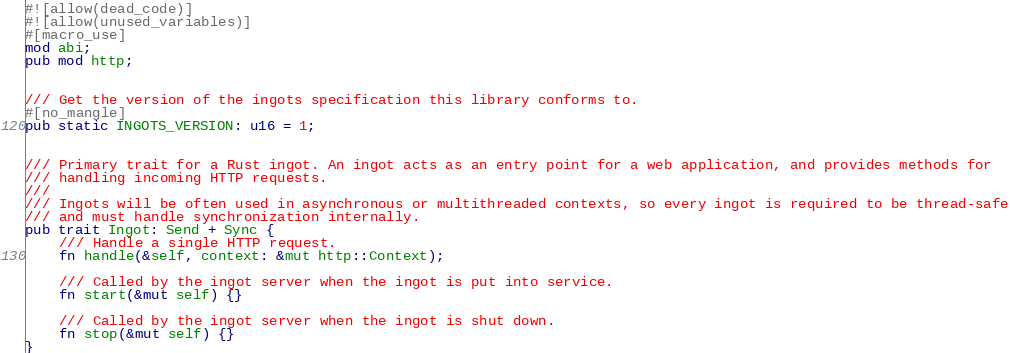<code> <loc_0><loc_0><loc_500><loc_500><_Rust_>#![allow(dead_code)]
#![allow(unused_variables)]
#[macro_use]
mod abi;
pub mod http;


/// Get the version of the ingots specification this library conforms to.
#[no_mangle]
pub static INGOTS_VERSION: u16 = 1;


/// Primary trait for a Rust ingot. An ingot acts as an entry point for a web application, and provides methods for
/// handling incoming HTTP requests.
///
/// Ingots will be often used in asynchronous or multithreaded contexts, so every ingot is required to be thread-safe
/// and must handle synchronization internally.
pub trait Ingot: Send + Sync {
    /// Handle a single HTTP request.
    fn handle(&self, context: &mut http::Context);

    /// Called by the ingot server when the ingot is put into service.
    fn start(&mut self) {}

    /// Called by the ingot server when the ingot is shut down.
    fn stop(&mut self) {}
}
</code> 